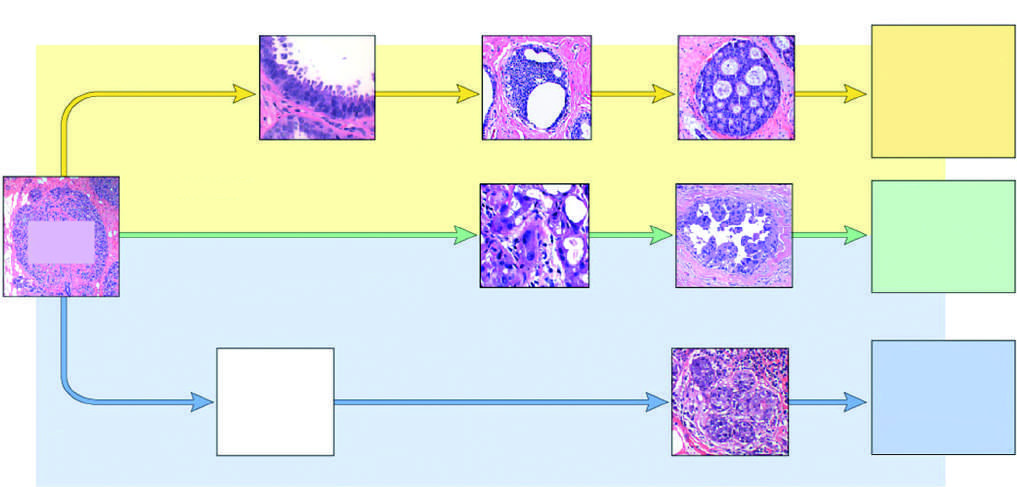does the most common pathway lead to er-positive cancers?
Answer the question using a single word or phrase. Yes 